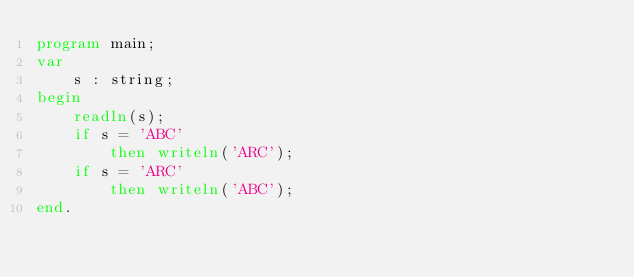<code> <loc_0><loc_0><loc_500><loc_500><_Pascal_>program main;
var
    s : string;
begin
    readln(s);
    if s = 'ABC'
        then writeln('ARC');
    if s = 'ARC'
        then writeln('ABC');
end.
</code> 